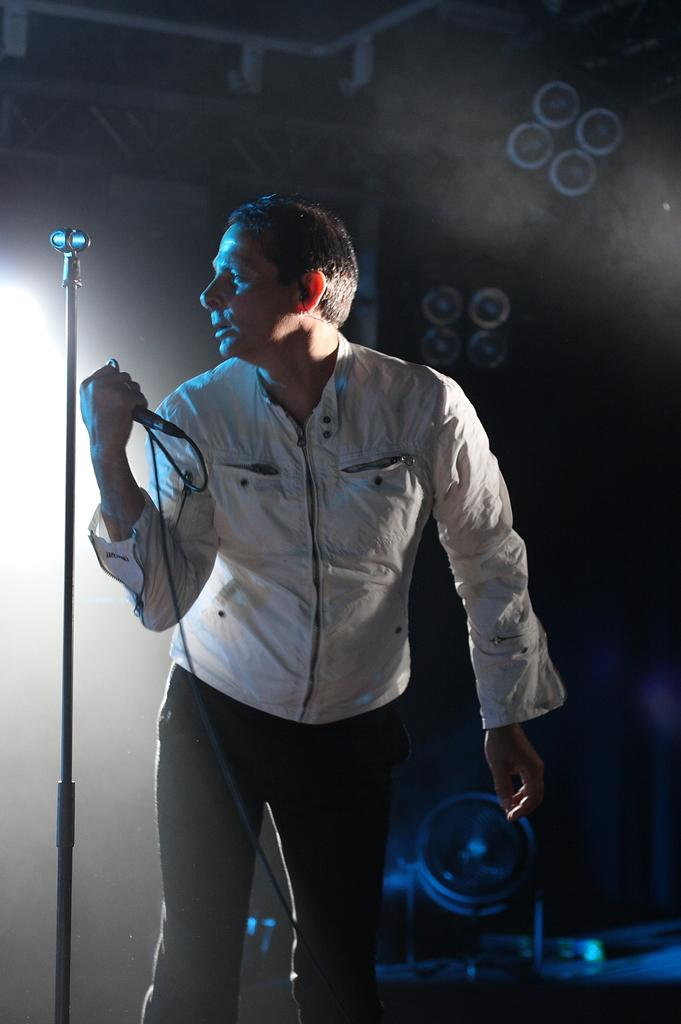What is the main subject of the image? There is a man in the image. What is the man doing in the image? The man is standing in front of a mic. How is the man interacting with the mic? The man is holding the mic in his hand. What is the man wearing in the image? The man is wearing a white shirt. What can be seen in the background of the image? There is a dark background and smoke visible in the background. What type of linen is draped over the man's shoulder in the image? There is no linen draped over the man's shoulder in the image. Is the man holding a gun in the image? No, the man is not holding a gun in the image; he is holding a mic. 